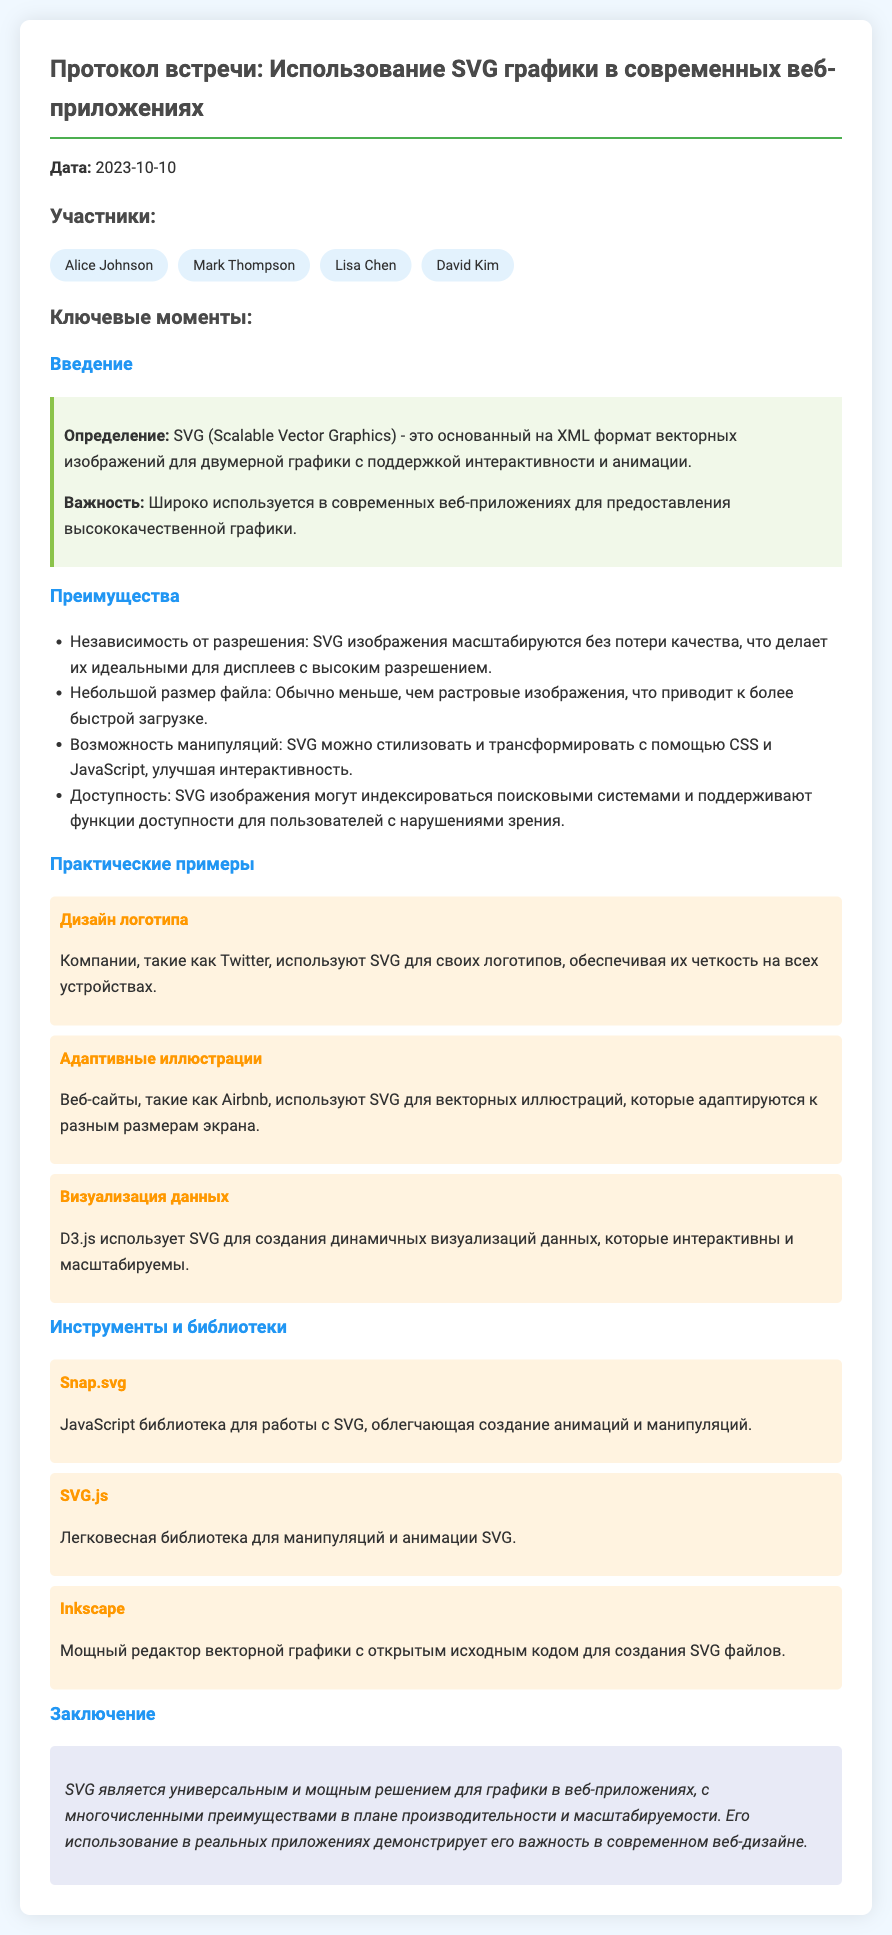что такое SVG? SVG (Scalable Vector Graphics) - это основанный на XML формат векторных изображений для двумерной графики с поддержкой интерактивности и анимации.
Answer: основанный на XML формат векторных изображений кто был участником встречи? Участниками встречи были упомянутые люди в разделе «Участники».
Answer: Alice Johnson, Mark Thompson, Lisa Chen, David Kim какие преимущества SVG? Преимущества SVG перечислены в разделе «Преимущества».
Answer: Независимость от разрешения, Небольшой размер файла, Возможность манипуляций, Доступность какой пример использования SVG для дизайна логотипа? В разделе «Практические примеры» показан пример использования SVG для логотипов.
Answer: компании, такие как Twitter назовите одну JavaScript библиотеку для работы с SVG. В разделе «Инструменты и библиотеки» упоминается несколько JavaScript библиотек для работы с SVG.
Answer: Snap.svg когда состоялась встреча? Дата встречи указана в начале документа.
Answer: 2023-10-10 какова итоговая идея использования SVG в веб-приложениях? Итоговая идея изложена в разделе «Заключение».
Answer: универсальным и мощным решением для графики в веб-приложениях что такое D3.js? D3.js упоминается в разделе «Практические примеры» как инструмент для визуализации данных с использованием SVG.
Answer: библиотека для создания динамичных визуализаций данных 